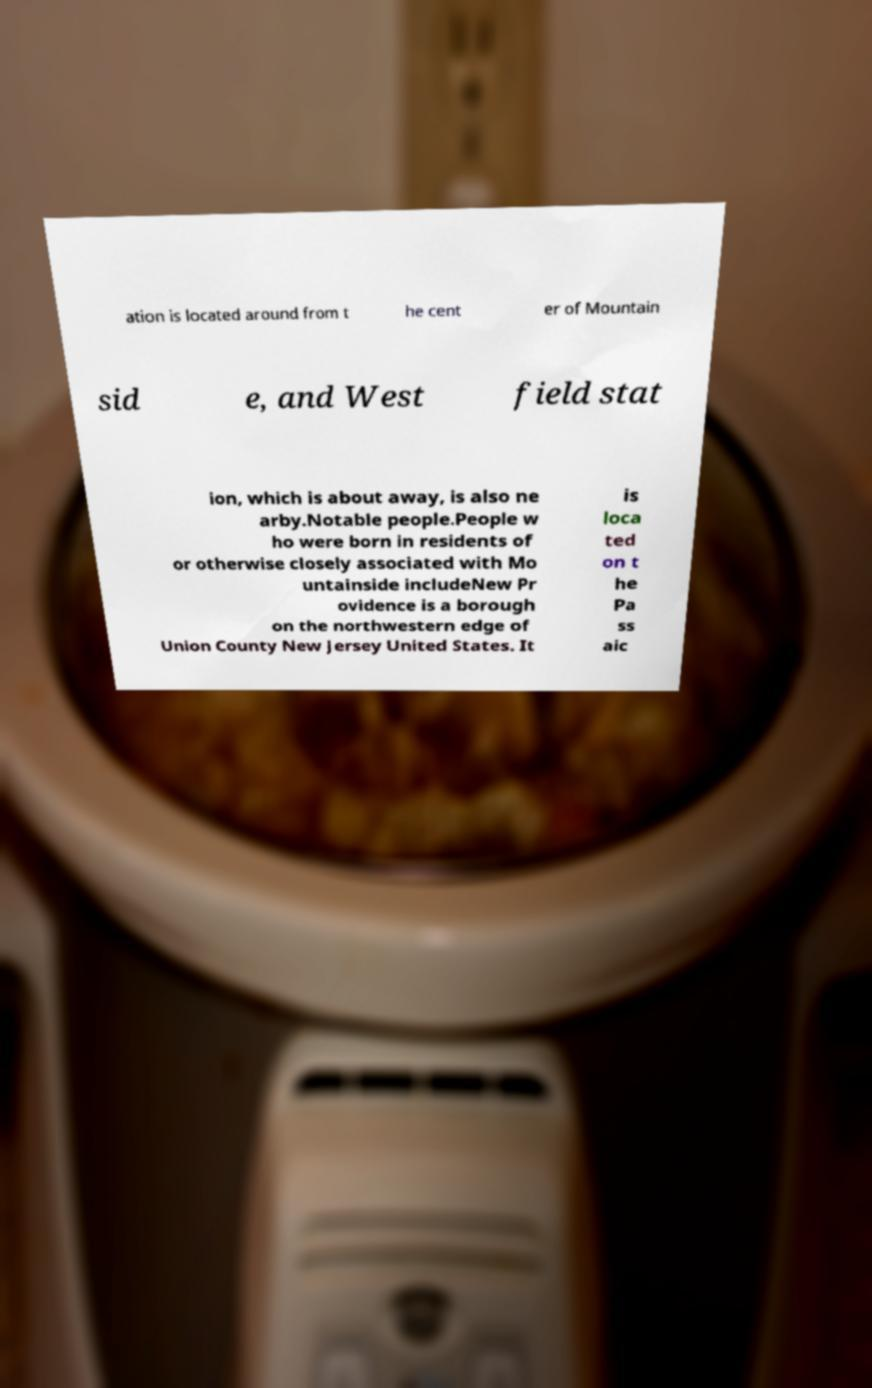Could you extract and type out the text from this image? ation is located around from t he cent er of Mountain sid e, and West field stat ion, which is about away, is also ne arby.Notable people.People w ho were born in residents of or otherwise closely associated with Mo untainside includeNew Pr ovidence is a borough on the northwestern edge of Union County New Jersey United States. It is loca ted on t he Pa ss aic 